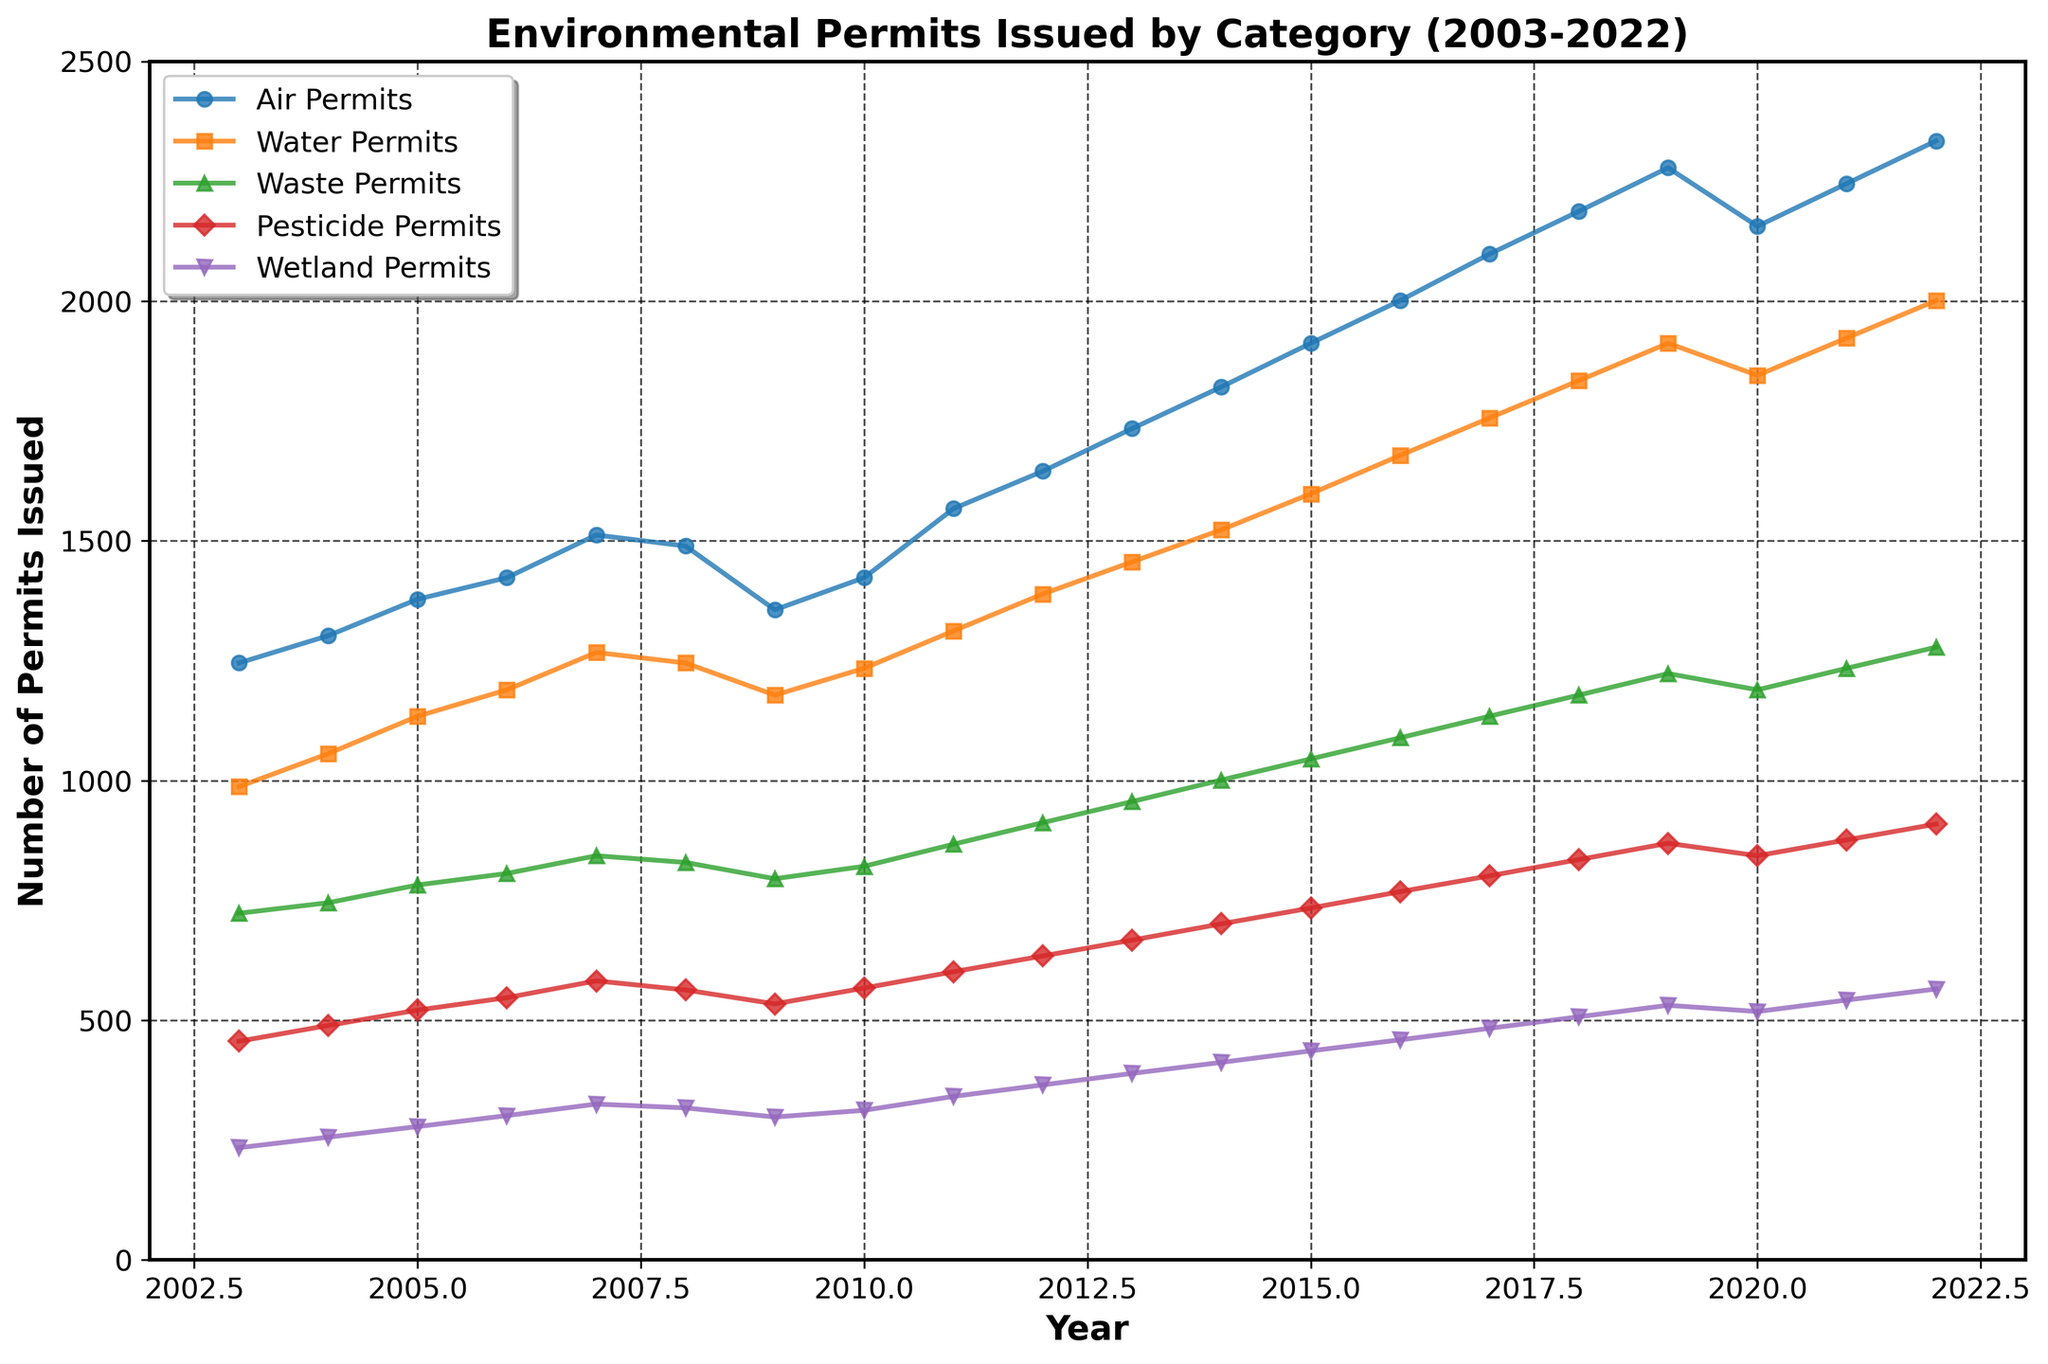How many more Air Permits were issued in 2022 compared to 2003? To find the difference, subtract the number of Air Permits issued in 2003 from the number issued in 2022. So, 2334 - 1245 = 1089
Answer: 1089 Which permit category had the highest increase in the number of permits issued from 2003 to 2022? First, calculate the increase for each permit category by subtracting the 2003 values from the 2022 values. Air Permits: 2334 - 1245 = 1089, Water Permits: 2001 - 987 = 1014, Waste Permits: 1278 - 723 = 555, Pesticide Permits: 909 - 456 = 453, Wetland Permits: 565 - 234 = 331. The highest increase is for Air Permits, which is 1089
Answer: Air Permits During which year did the number of Pesticide Permits peak? By inspecting the trend line for Pesticide Permits, the peak is at the highest point in the corresponding year, which is 2022 with 909 permits issued
Answer: 2022 What is the average number of Waste Permits issued from 2003 to 2022? To find the average, sum the number of Waste Permits issued each year and divide by the total number of years. Sum: 723 + 745 + 782 + 806 + 843 + 829 + 795 + 821 + 867 + 912 + 956 + 1001 + 1045 + 1089 + 1134 + 1178 + 1223 + 1189 + 1234 + 1278 = 18750. Average = 18750 / 20 = 937.5
Answer: 937.5 Compare the trends of Water Permits and Wetland Permits from 2010 to 2020. Which category shows a more significant increase? Calculate the difference for each category within this period. Water Permits: 1845 - 1234 = 611. Wetland Permits: 518 - 312 = 206. Water Permits show a more significant increase of 611 compared to 206 for Wetland Permits
Answer: Water Permits In which year did the number of Air Permits surpass 2000 for the first time? Inspect the Air Permits trend line to find the first year where the value exceeds 2000, which is 2016
Answer: 2016 What is the combined number of Waste Permits and Wetland Permits issued in 2014? Add the number of Waste Permits and Wetland Permits issued in 2014. Waste Permits: 1001, Wetland Permits: 412. Combined = 1001 + 412 = 1413
Answer: 1413 By how much did the number of Air Permits change from 2019 to 2020? Compare the number of Air Permits in 2019 and 2020. The change is 2156 - 2278 = -122, indicating a decrease of 122
Answer: -122 What was the trend for Water Permits from 2009 to 2013? Inspect the Water Permits line segment from 2009 to 2013. The values are progressively increasing: 1178 to 1456. The trend indicates an upward trend
Answer: Upward trend Which category shows the most stable trend from 2003 to 2022? Stability can be interpreted by the least fluctuation or most linear trend. Inspect all trend lines visually for smoothness. The Pesticide Permits show the most stable trend with small, consistent increases
Answer: Pesticide Permits 